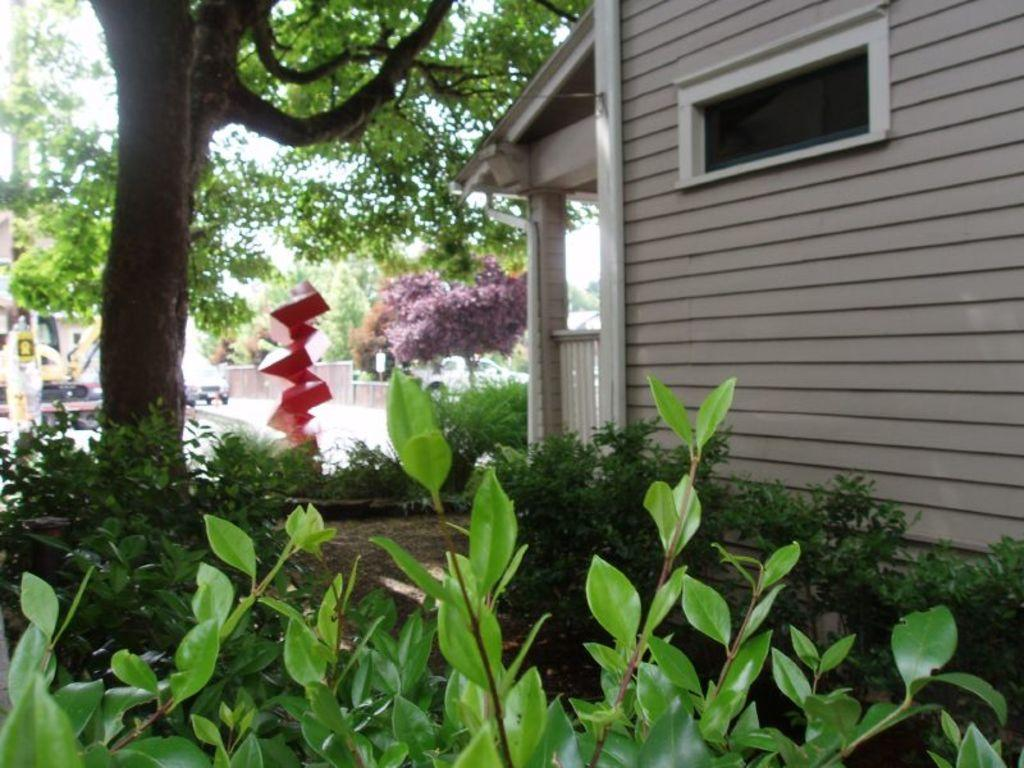What type of living organisms can be seen in the image? Plants and trees are visible in the image. What type of structures are present in the image? There are buildings in the image. What type of transportation is visible in the image? There are vehicles in the image. How many apples can be seen hanging from the trees in the image? There are no apples visible in the image; only plants, trees, buildings, and vehicles are present. What type of crack is visible on the surface of the building in the image? There is no crack visible on the surface of the building in the image. 